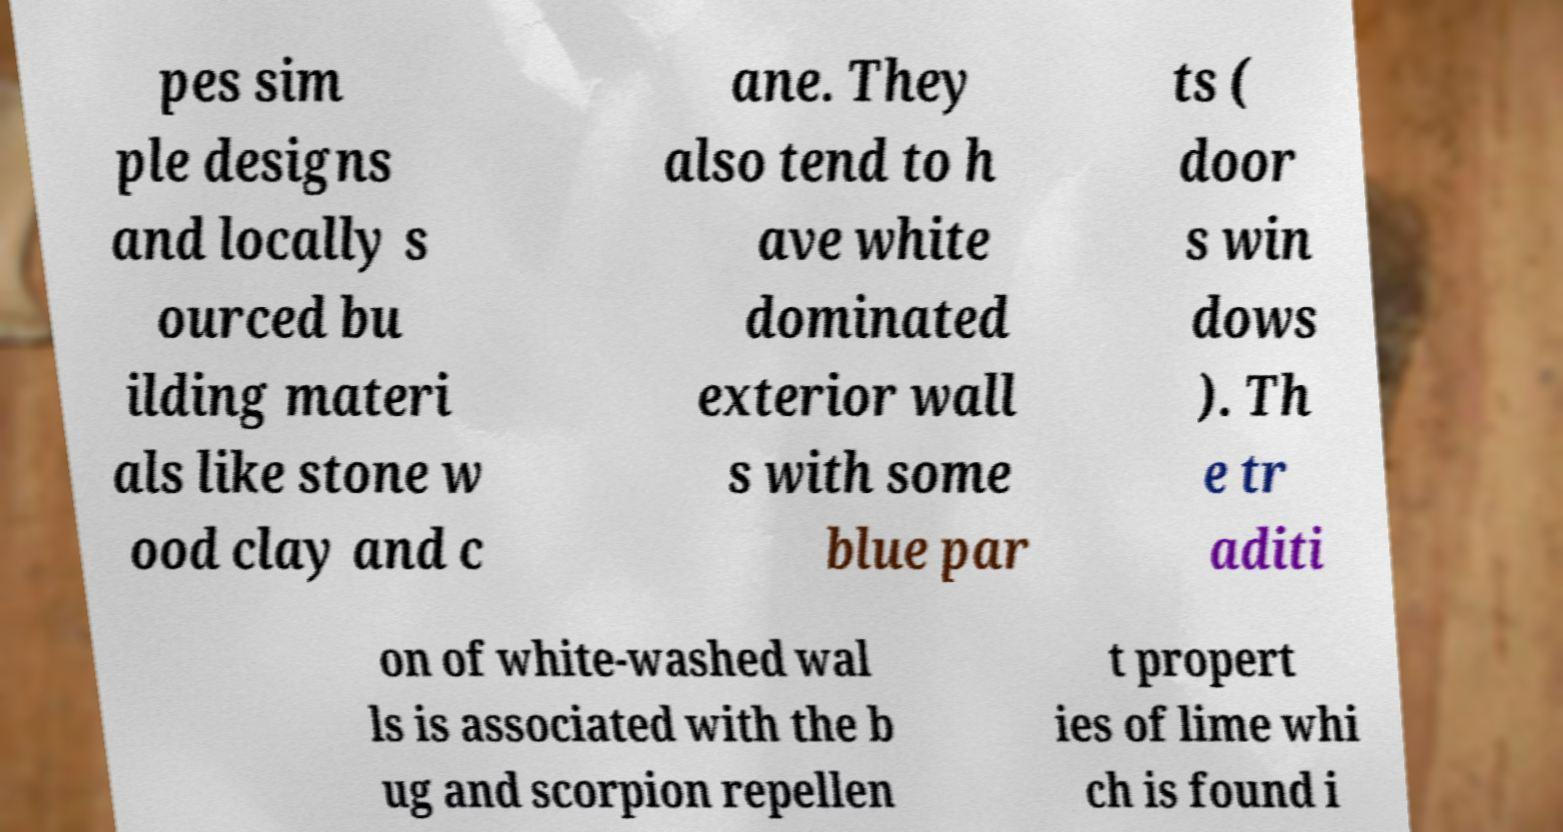There's text embedded in this image that I need extracted. Can you transcribe it verbatim? pes sim ple designs and locally s ourced bu ilding materi als like stone w ood clay and c ane. They also tend to h ave white dominated exterior wall s with some blue par ts ( door s win dows ). Th e tr aditi on of white-washed wal ls is associated with the b ug and scorpion repellen t propert ies of lime whi ch is found i 